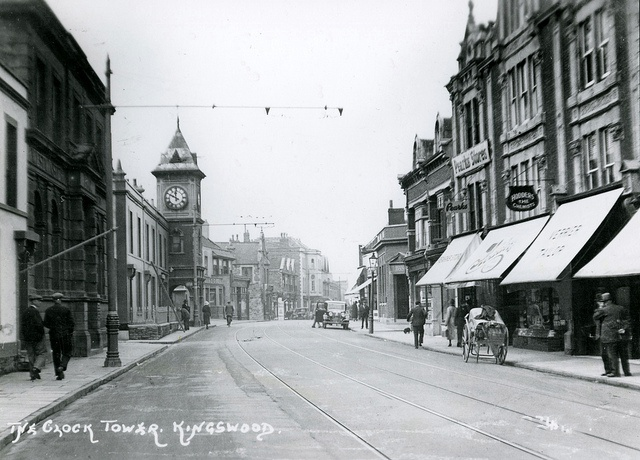Describe the objects in this image and their specific colors. I can see people in gray, black, and darkgray tones, people in gray, black, and darkgray tones, people in gray and black tones, car in gray, darkgray, lightgray, and black tones, and clock in gray, darkgray, lightgray, and black tones in this image. 